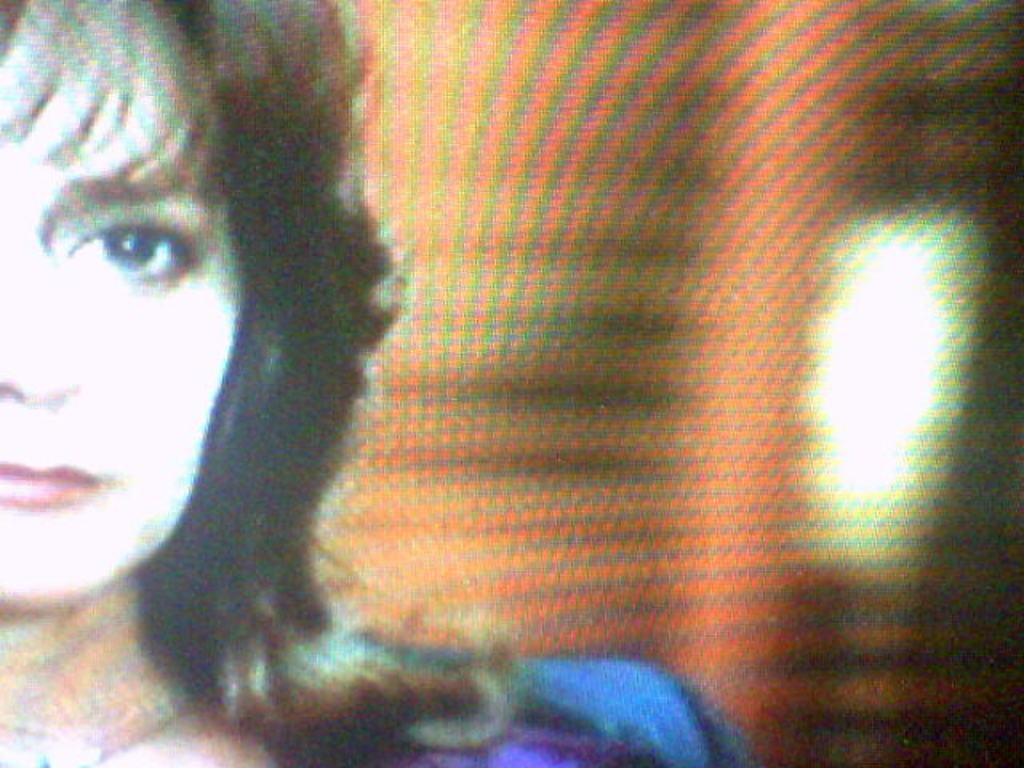What is the main object in the image? There is a screen in the image. What can be seen on the screen? There is a woman on the screen. What is the woman wearing? The woman is wearing a blue dress. How many guns can be seen on the woman's dress in the image? There are no guns visible on the woman's dress in the image. What type of spiders are crawling on the screen in the image? There are no spiders present in the image; it only features a woman on the screen. 